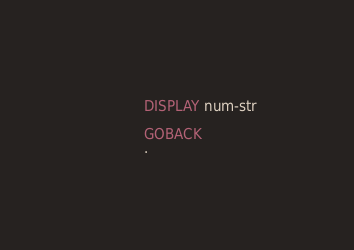<code> <loc_0><loc_0><loc_500><loc_500><_COBOL_>           DISPLAY num-str

           GOBACK
           .
</code> 